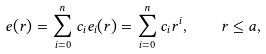<formula> <loc_0><loc_0><loc_500><loc_500>e ( r ) = \sum _ { i = 0 } ^ { n } c _ { i } e _ { i } ( r ) = \sum _ { i = 0 } ^ { n } c _ { i } r ^ { i } , \quad r \leq a ,</formula> 